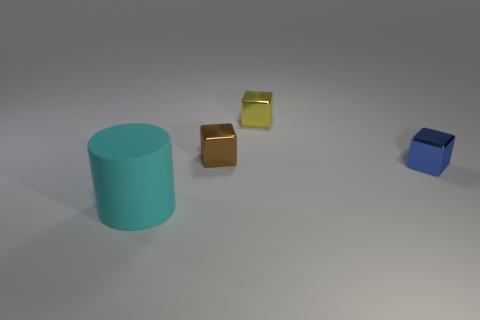Add 1 big matte objects. How many objects exist? 5 Subtract all cubes. How many objects are left? 1 Add 1 brown cubes. How many brown cubes are left? 2 Add 1 large red metal cubes. How many large red metal cubes exist? 1 Subtract 0 cyan balls. How many objects are left? 4 Subtract all tiny yellow metal blocks. Subtract all big rubber cylinders. How many objects are left? 2 